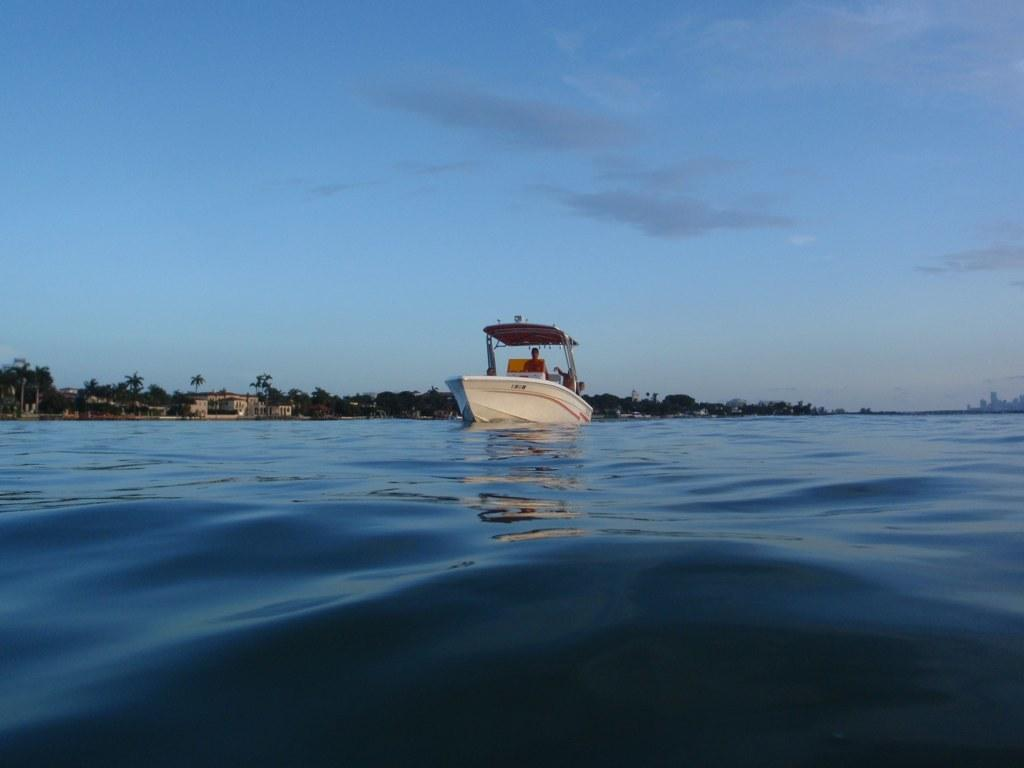What is the main subject of the image? There is a person on a boat in the image. What can be seen in the background of the image? There are trees and buildings in the background of the image. What is visible at the bottom of the image? There is water visible at the bottom of the image. What is visible at the top of the image? There is sky visible at the top of the image. What color of paint is being used by the person on the boat in the image? There is no indication in the image that the person on the boat is using paint, so it cannot be determined from the picture. 